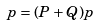Convert formula to latex. <formula><loc_0><loc_0><loc_500><loc_500>p = ( P + Q ) p</formula> 